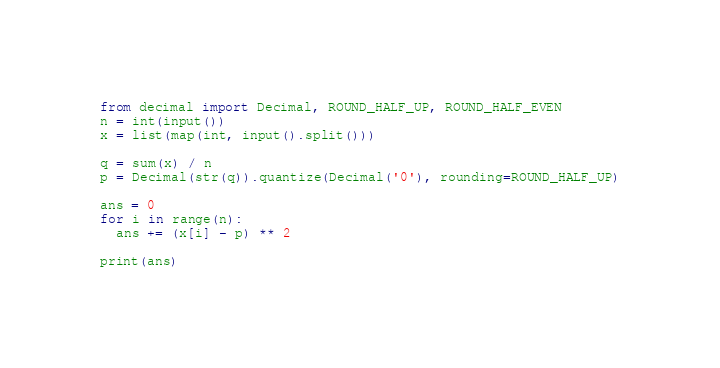<code> <loc_0><loc_0><loc_500><loc_500><_Python_>from decimal import Decimal, ROUND_HALF_UP, ROUND_HALF_EVEN
n = int(input())
x = list(map(int, input().split()))

q = sum(x) / n
p = Decimal(str(q)).quantize(Decimal('0'), rounding=ROUND_HALF_UP)

ans = 0
for i in range(n):
  ans += (x[i] - p) ** 2

print(ans)</code> 